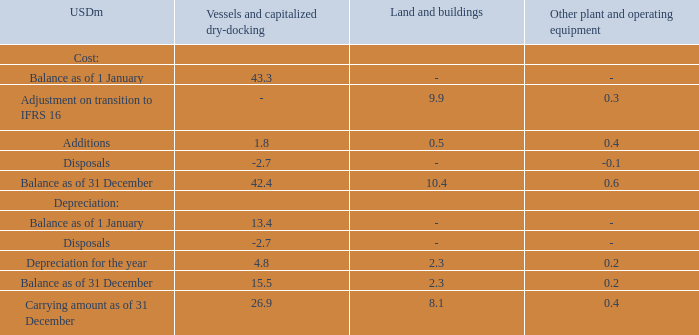NOTE 7 – LEASING
TORM has leases for the office buildings, some vehicles and other administrative equipment. With the exception of short-term leases and leases of low-value assets, each lease is reflected on the balance sheet as a right-of-use asset with a corresponding lease liability. The right-of-use assets are included in the financial statement line item in which the corresponding underlying assets would be presented if they were owned. Please refer to note 6.
As of 31 December 2019, TORM had recognized the following right-of-use assets:
What does TORM have leases for? The office buildings, some vehicles and other administrative equipment. How is each lease reflected on the balance sheet? As a right-of-use asset with a corresponding lease liability. the right-of-use assets are included in the financial statement line item in which the corresponding underlying assets would be presented if they were owned. What are the types of right-of-use assets considered in the table? Vessels and capitalized dry-docking, land and buildings, other plant and operating equipment. Which asset type has the largest depreciation of the year? 4.8>2.3>0.2
Answer: vessels and capitalized dry-docking. What was the change in the depreciation balance as of 31 December from 1 January in 2019 for vessels and capitalized dry-docking?
Answer scale should be: million. 15.5-13.4
Answer: 2.1. What was the percentage change in the depreciation balance as of 31 December from 1 January in 2019 for vessels and capitalized dry-docking?
Answer scale should be: percent. (15.5-13.4)/13.4
Answer: 15.67. 